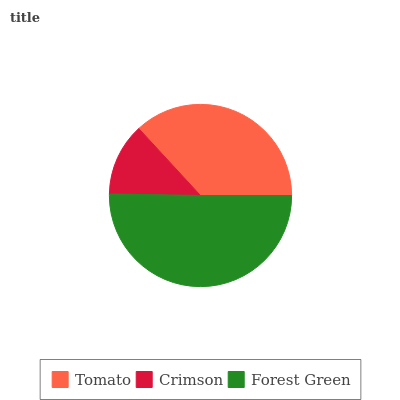Is Crimson the minimum?
Answer yes or no. Yes. Is Forest Green the maximum?
Answer yes or no. Yes. Is Forest Green the minimum?
Answer yes or no. No. Is Crimson the maximum?
Answer yes or no. No. Is Forest Green greater than Crimson?
Answer yes or no. Yes. Is Crimson less than Forest Green?
Answer yes or no. Yes. Is Crimson greater than Forest Green?
Answer yes or no. No. Is Forest Green less than Crimson?
Answer yes or no. No. Is Tomato the high median?
Answer yes or no. Yes. Is Tomato the low median?
Answer yes or no. Yes. Is Forest Green the high median?
Answer yes or no. No. Is Forest Green the low median?
Answer yes or no. No. 